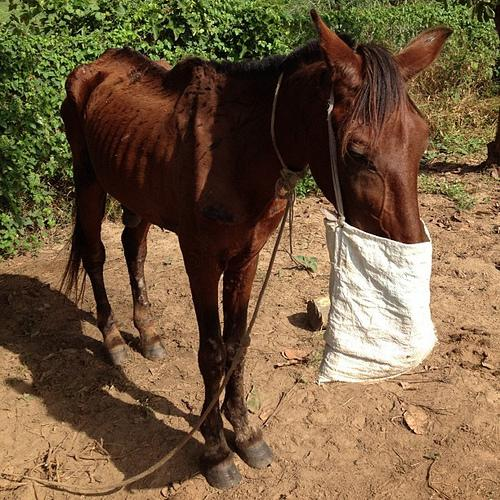Name a distinctive component of the horse's appearance, particularly relating to its head. The horse has a black mane on the front of its head. Is there any visible mark or imperfection on the animal's leg? If yes, provide the details. There are sores on the horse's left rear leg. Analyze the horse's surroundings and mention the type of plants in the background. Bushes and sparse green growth are seen behind the horse, with a hedge further back. Assess the horse's emotional state based on its facial features and provide a description. The horse has downtrodden eyes, giving it an ill appearance. Determine an action being performed by the horse at the time this image was captured. The horse is feeding from a white bag covering its snout. Describe the feeding equipment on the horse's face and its position. The horse has a white feed bag over its muzzle, covering its snout, from which it is eating. Identify the primary animal in the image and its prominent physical feature. A thin brown horse with visible ribs is present in the image. Describe the elements used to restrain the horse and their positions. There is a rope tie around the horse's neck, holding it in place. Explain the state of the horse's health and a possible reason for it. The horse appears to be severely malnourished possibly due to a lack of adequate food. What color is the ground in the image and what can be found on it? The ground is brown color, and green grass and dirt can be found on it. Consider the puddle of mud near the horse's hooves; it must be the result of recent rain in the area. Do not miss it out! No, it's not mentioned in the image. Can you locate the vibrant red apple next to the horse? Be sure it's situated near the bush. There is no mention of a red apple in the given information, and thus it is a misleading instruction. 